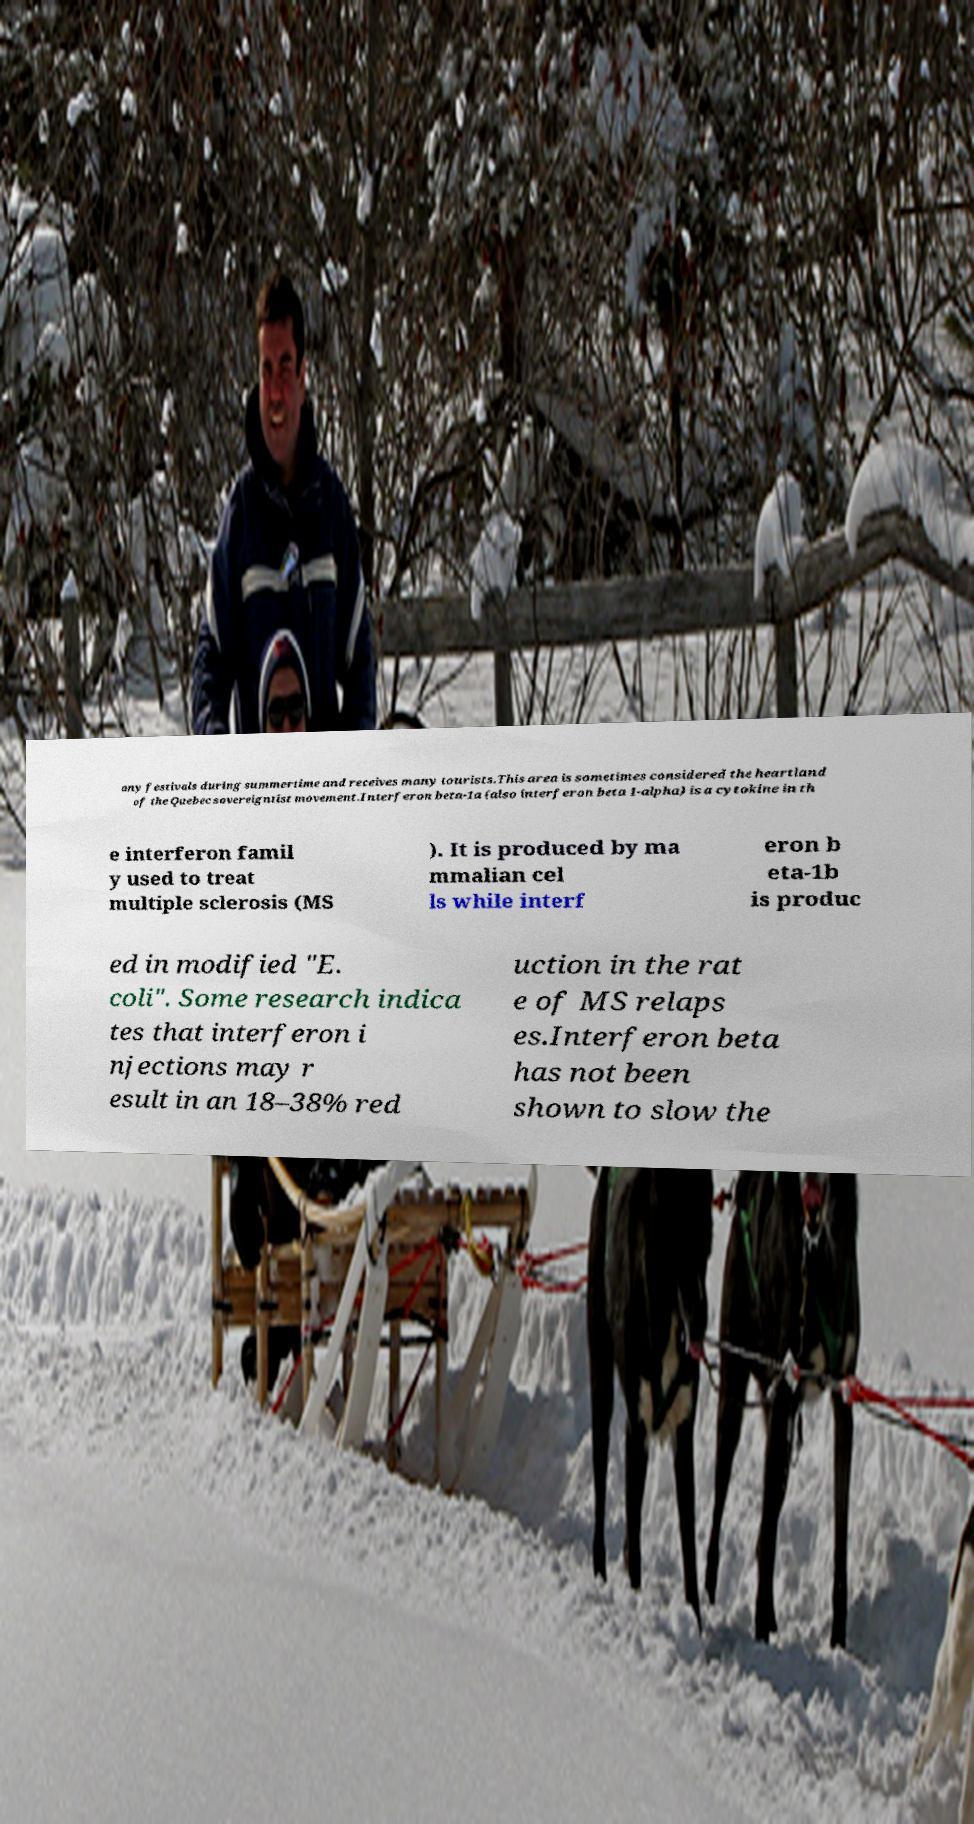For documentation purposes, I need the text within this image transcribed. Could you provide that? any festivals during summertime and receives many tourists.This area is sometimes considered the heartland of the Quebec sovereigntist movement.Interferon beta-1a (also interferon beta 1-alpha) is a cytokine in th e interferon famil y used to treat multiple sclerosis (MS ). It is produced by ma mmalian cel ls while interf eron b eta-1b is produc ed in modified "E. coli". Some research indica tes that interferon i njections may r esult in an 18–38% red uction in the rat e of MS relaps es.Interferon beta has not been shown to slow the 